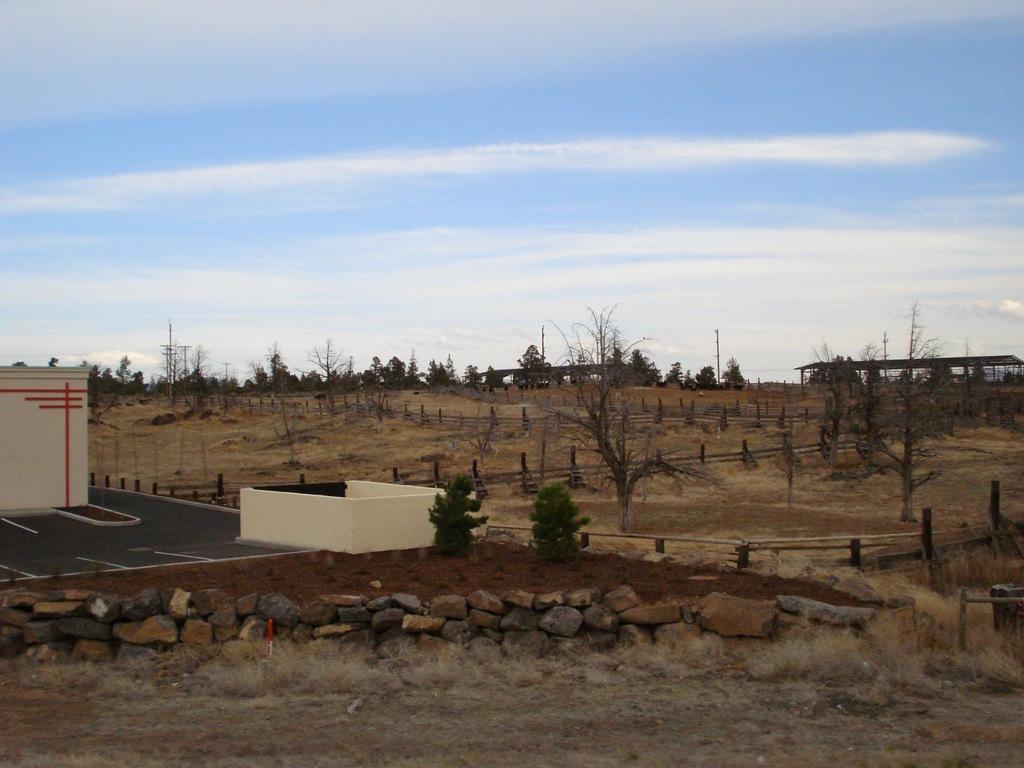Describe this image in one or two sentences. In the foreground of the picture there are stones, grass and soil. In the center of the picture there are trees, fencing, buildings. In the top it is sky, sky is little bit cloudy. 